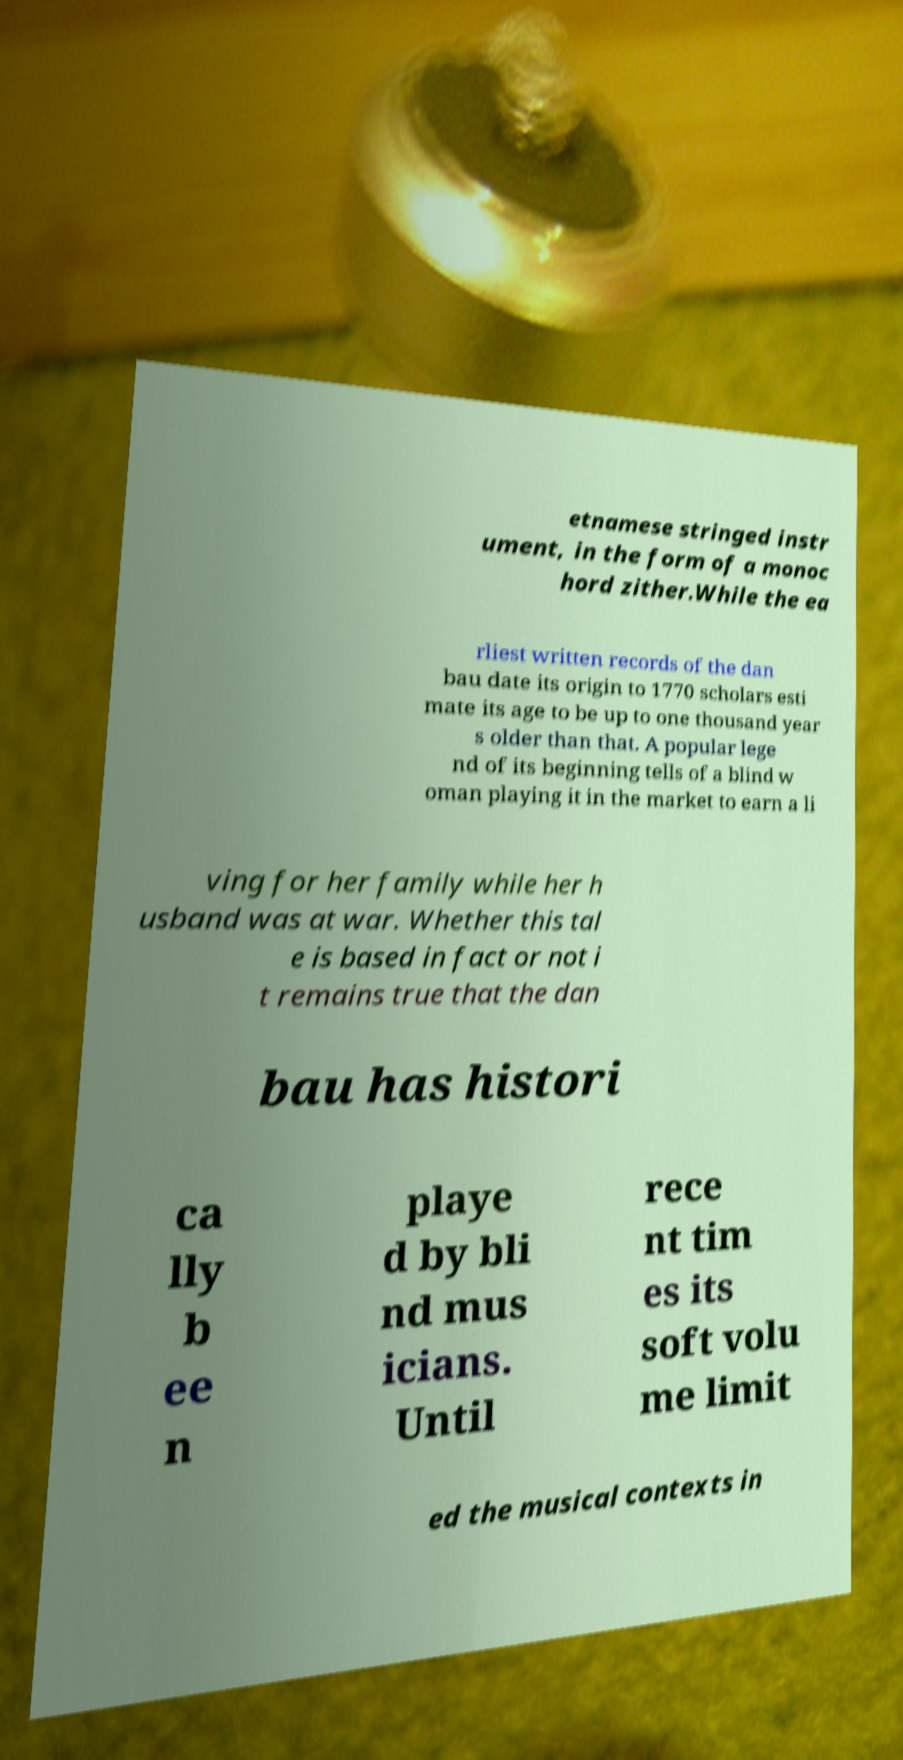What messages or text are displayed in this image? I need them in a readable, typed format. etnamese stringed instr ument, in the form of a monoc hord zither.While the ea rliest written records of the dan bau date its origin to 1770 scholars esti mate its age to be up to one thousand year s older than that. A popular lege nd of its beginning tells of a blind w oman playing it in the market to earn a li ving for her family while her h usband was at war. Whether this tal e is based in fact or not i t remains true that the dan bau has histori ca lly b ee n playe d by bli nd mus icians. Until rece nt tim es its soft volu me limit ed the musical contexts in 